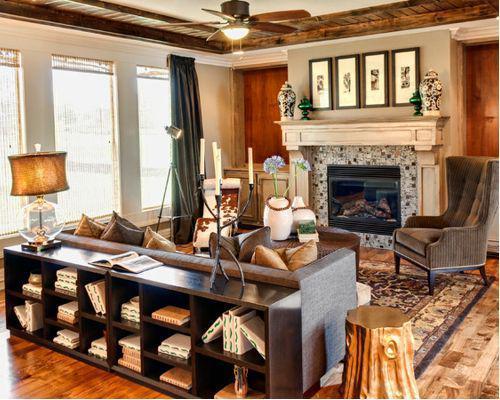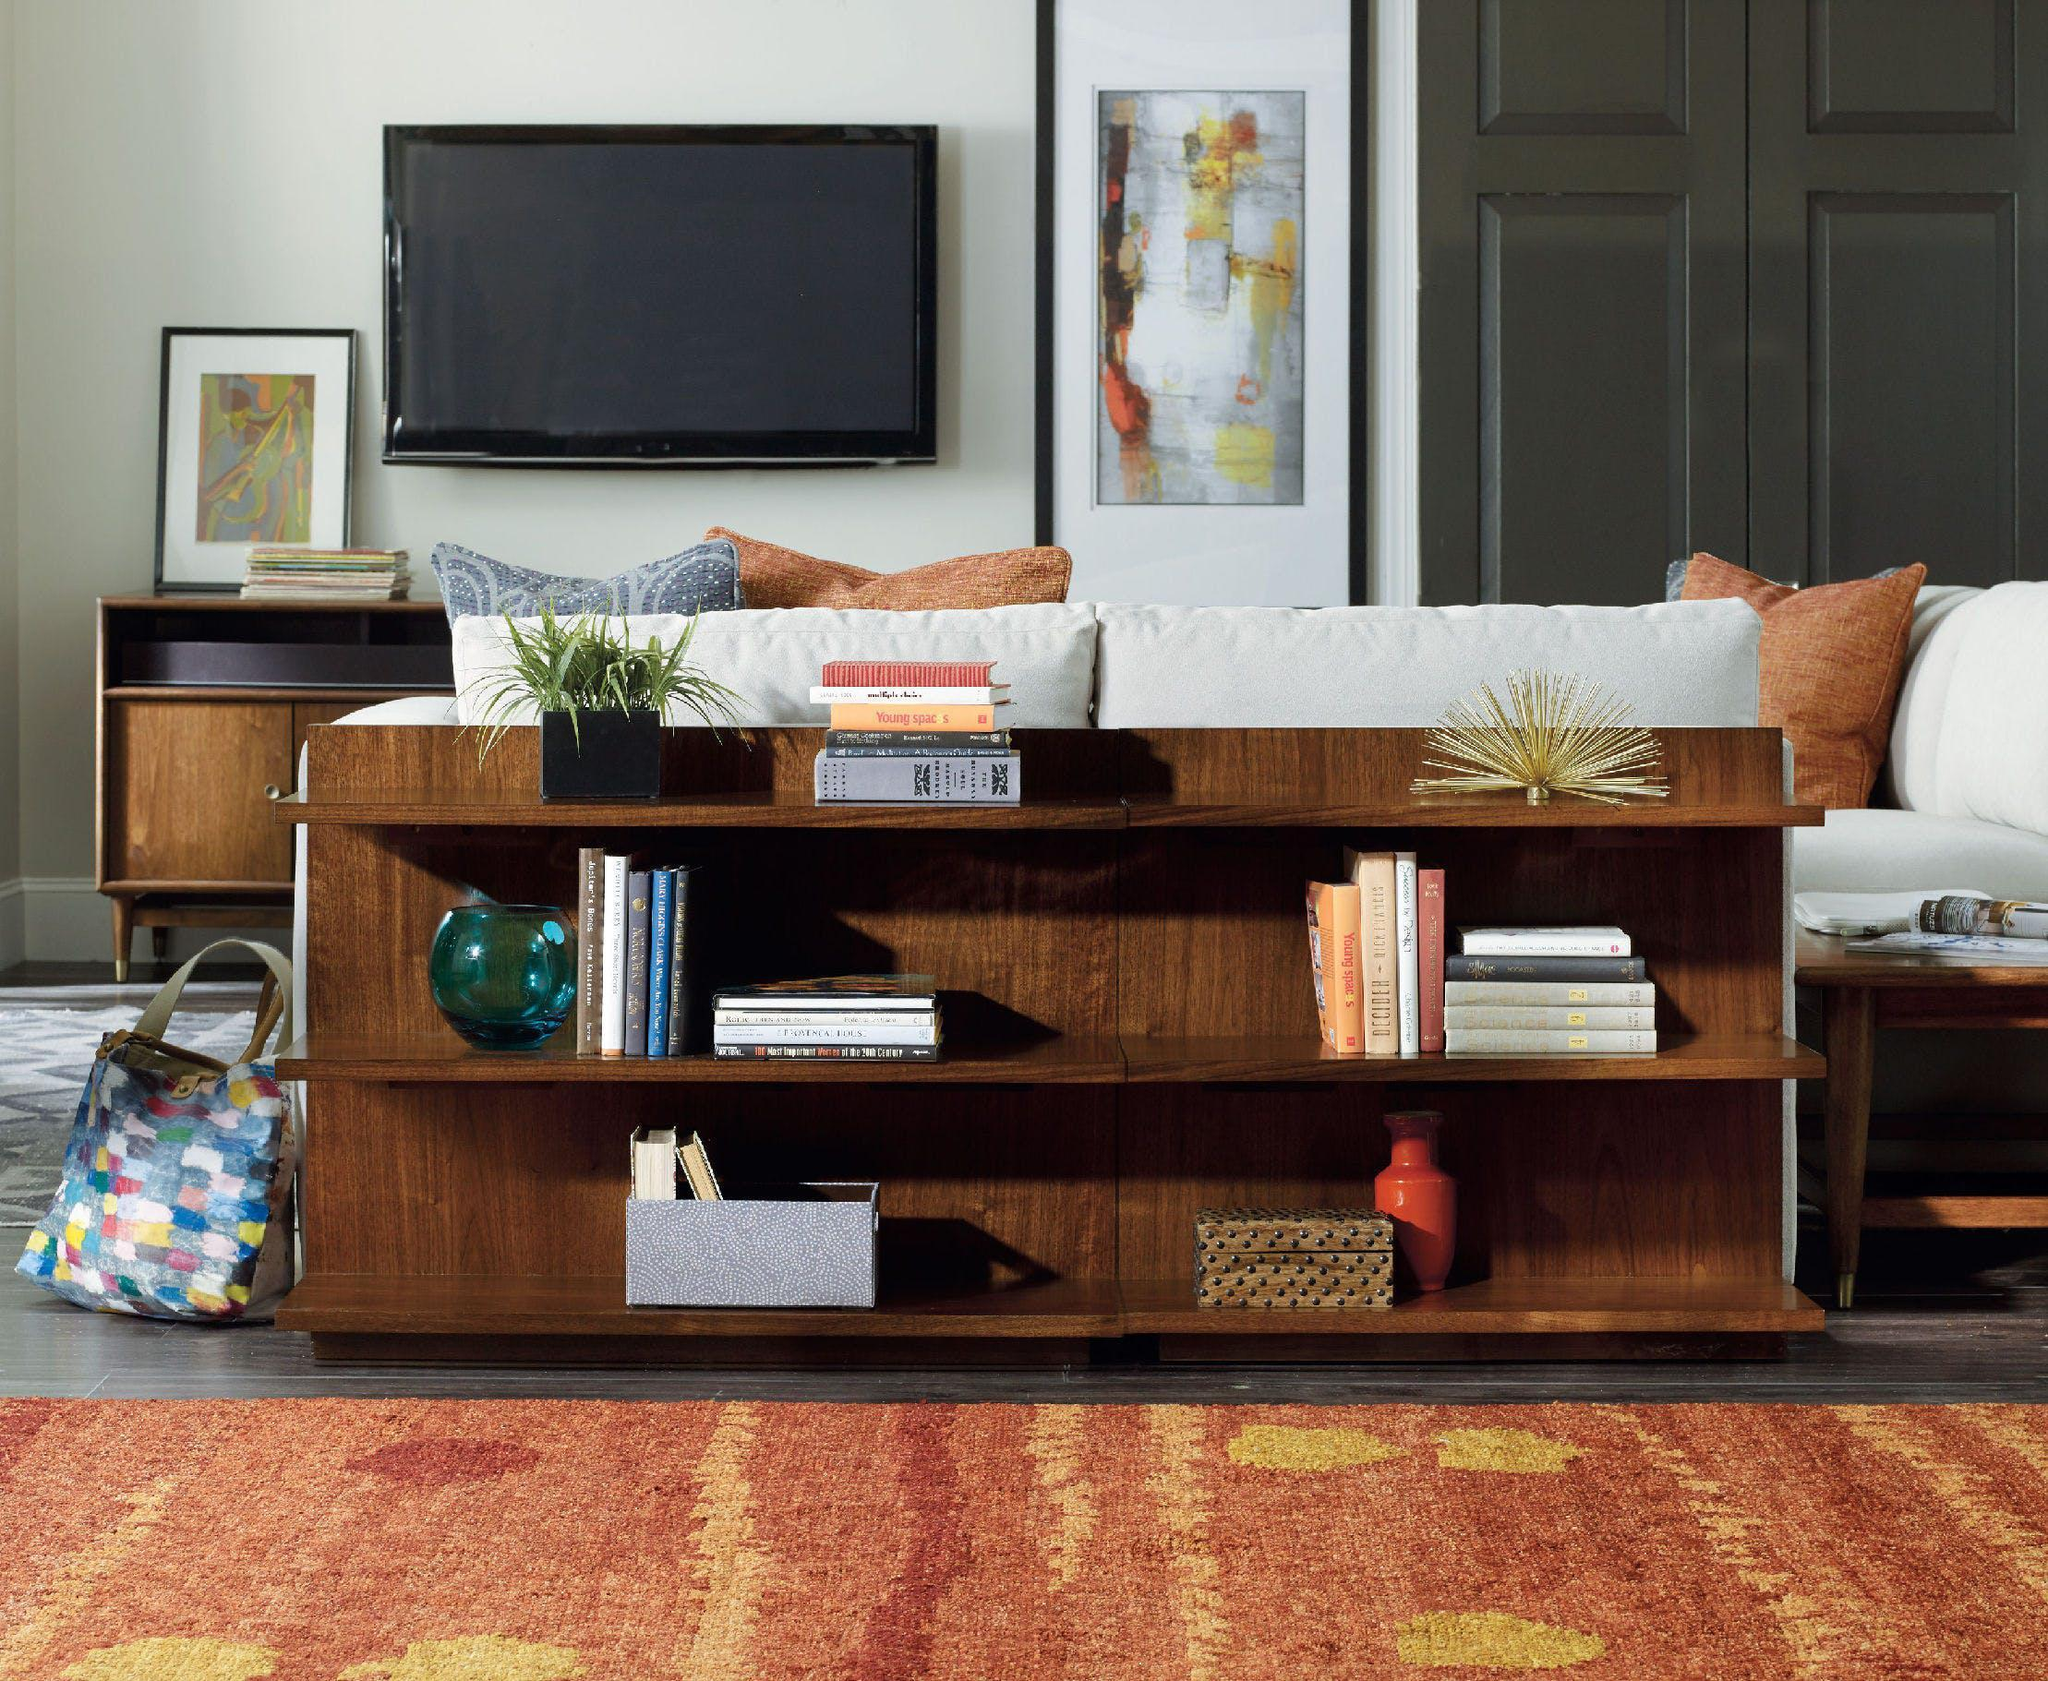The first image is the image on the left, the second image is the image on the right. Considering the images on both sides, is "there is a bookself with a rug on a wood floor" valid? Answer yes or no. Yes. 